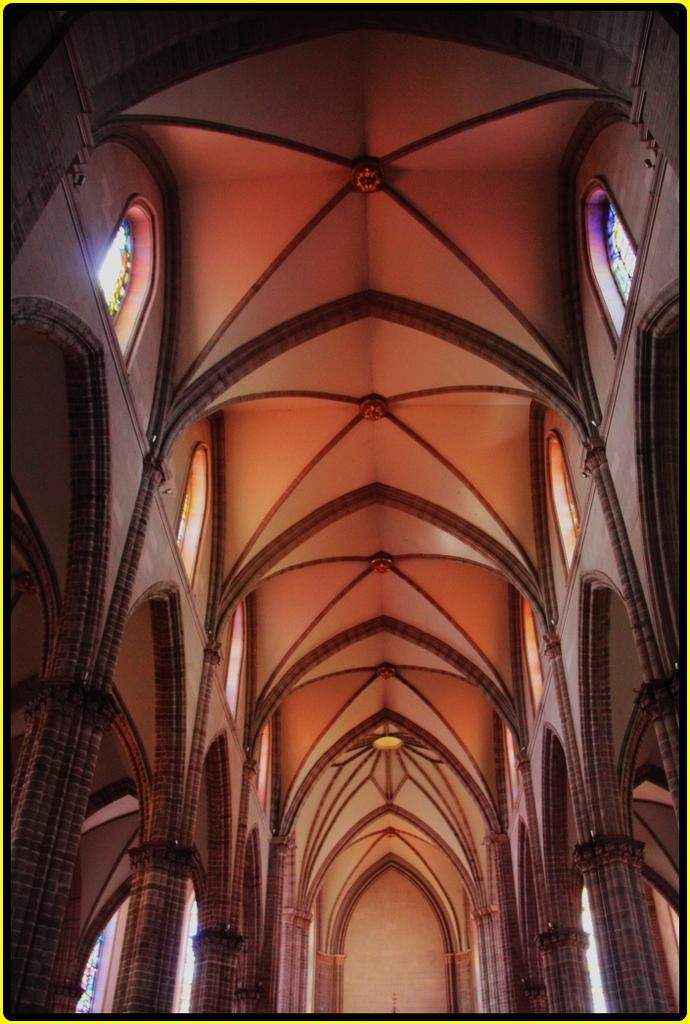What type of view is shown in the image? The image is an inside view of a building. What architectural features can be seen on the right side of the image? There are pillars on the right side of the image. What architectural features can be seen on the left side of the image? There are pillars on the left side of the image. What is visible in the background of the image? There is a wall in the background of the image. What can be seen at the top of the image? There are windows at the top of the image. How many frogs are sitting on the glove in the image? There are no frogs or gloves present in the image. What type of fiction is being read by the person in the image? There is no person or fiction visible in the image. 